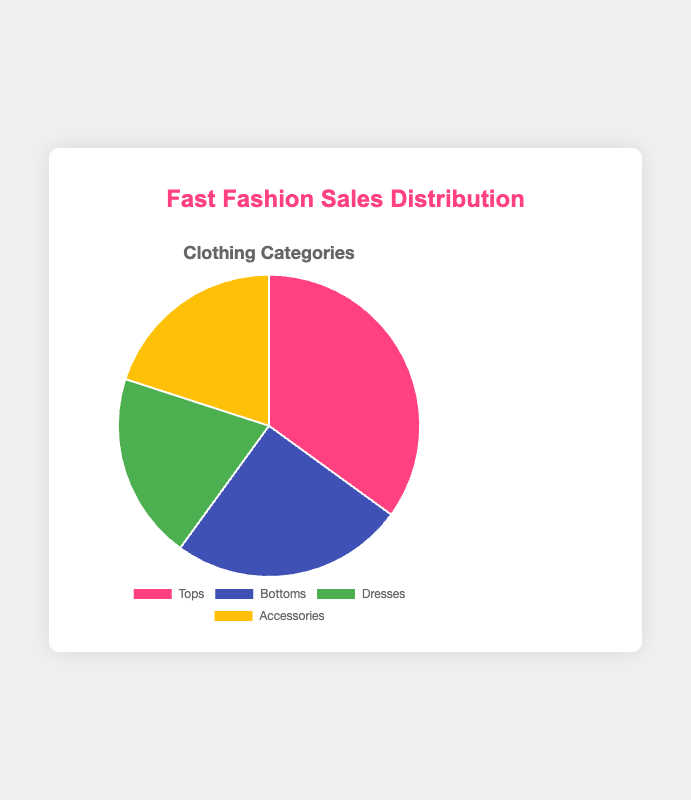What percentage of the sales distribution does the Dresses category represent? The Dresses category represents 20% of the sales distribution, as indicated in the pie chart.
Answer: 20% Which category has the largest sales percentage? The category with the largest sales percentage is Tops, accounting for 35% of the total distribution.
Answer: Tops How much greater is the sales percentage for Tops compared to Bottoms? To find the difference, subtract the percentage of Bottoms from the percentage of Tops: 35% - 25% = 10%.
Answer: 10% Are Dresses and Accessories categories equal in their sales percentages? Yes, both Dresses and Accessories each account for 20% of the sales distribution, making their percentages equal.
Answer: Yes By how much do Bottoms sales percentage differ from Accessories sales percentage? The sales percentages for Bottoms and Accessories differ by 5%, calculated as 25% - 20%.
Answer: 5% If the total sales were $100,000, how much would the Accessories category represent in dollar value? Accessories account for 20% of the total sales. Therefore, 20% of $100,000 is calculated as (20/100) * $100,000 = $20,000
Answer: $20,000 Combine the sales percentages of Dresses and Bottoms. What is the resulting sum? The sum of the sales percentages of Dresses and Bottoms is 20% + 25% = 45%.
Answer: 45% What is the average sales percentage across all categories? To find the average, sum all the percentages and divide by the number of categories. (35% + 25% + 20% + 20%) / 4 = 100% / 4 = 25%.
Answer: 25% Which category is shown in blue and what is its percentage? Bottoms category is shown in blue and it represents 25% of the sales distribution.
Answer: Bottoms, 25% Which two categories combined have the same percentage as the Tops category? Dresses and Accessories combined have the same percentage as Tops. Their combined percentage is 20% + 20% = 40%, which is 5% more than Tops' 35%. So there are no categories combined that equal the Tops exactly.
Answer: None 